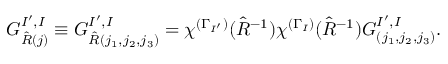Convert formula to latex. <formula><loc_0><loc_0><loc_500><loc_500>G _ { \hat { R } ( j ) } ^ { I ^ { \prime } , I } \equiv G _ { \hat { R } ( j _ { 1 } , j _ { 2 } , j _ { 3 } ) } ^ { I ^ { \prime } , I } = \chi ^ { ( \Gamma _ { I ^ { \prime } } ) } ( \hat { R } ^ { - 1 } ) \chi ^ { ( \Gamma _ { I } ) } ( \hat { R } ^ { - 1 } ) G _ { ( j _ { 1 } , j _ { 2 } , j _ { 3 } ) } ^ { I ^ { \prime } , I } .</formula> 